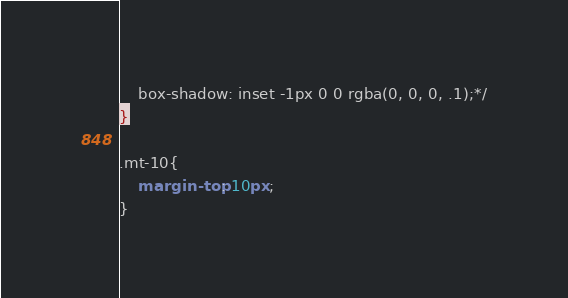<code> <loc_0><loc_0><loc_500><loc_500><_CSS_>	box-shadow: inset -1px 0 0 rgba(0, 0, 0, .1);*/
}

.mt-10{
	margin-top: 10px;
}</code> 